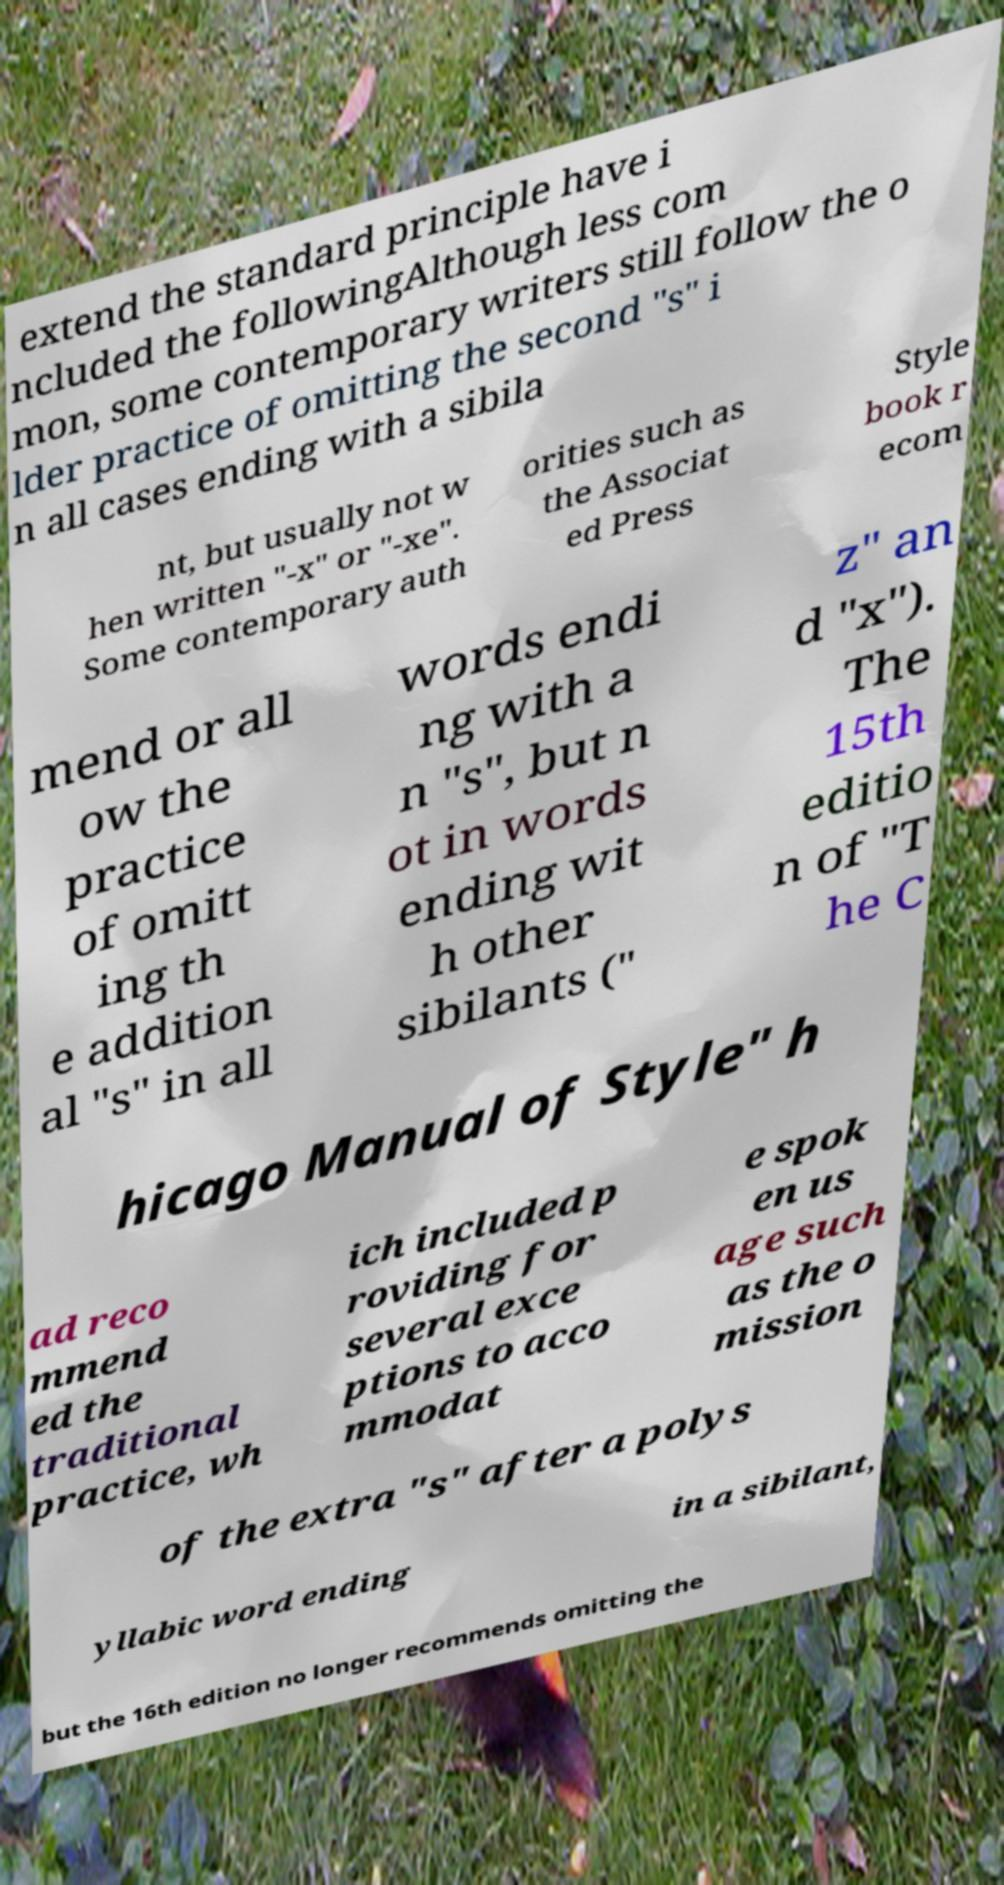For documentation purposes, I need the text within this image transcribed. Could you provide that? extend the standard principle have i ncluded the followingAlthough less com mon, some contemporary writers still follow the o lder practice of omitting the second "s" i n all cases ending with a sibila nt, but usually not w hen written "-x" or "-xe". Some contemporary auth orities such as the Associat ed Press Style book r ecom mend or all ow the practice of omitt ing th e addition al "s" in all words endi ng with a n "s", but n ot in words ending wit h other sibilants (" z" an d "x"). The 15th editio n of "T he C hicago Manual of Style" h ad reco mmend ed the traditional practice, wh ich included p roviding for several exce ptions to acco mmodat e spok en us age such as the o mission of the extra "s" after a polys yllabic word ending in a sibilant, but the 16th edition no longer recommends omitting the 